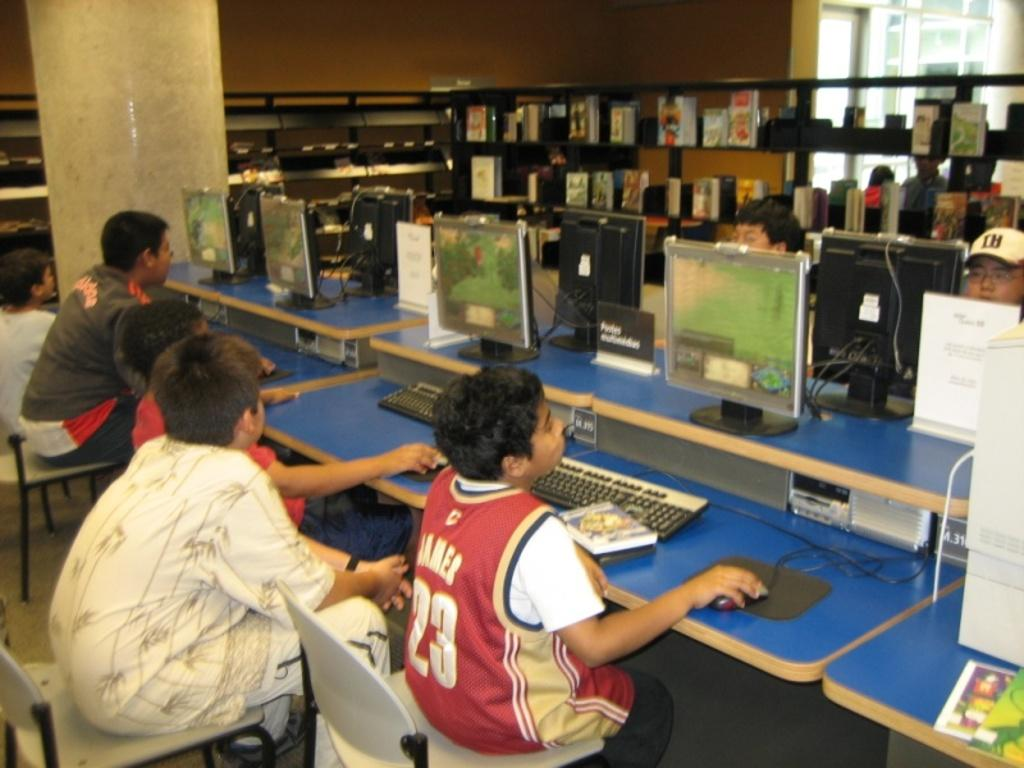<image>
Render a clear and concise summary of the photo. a boy with the number 23 on his jersey in a game room 